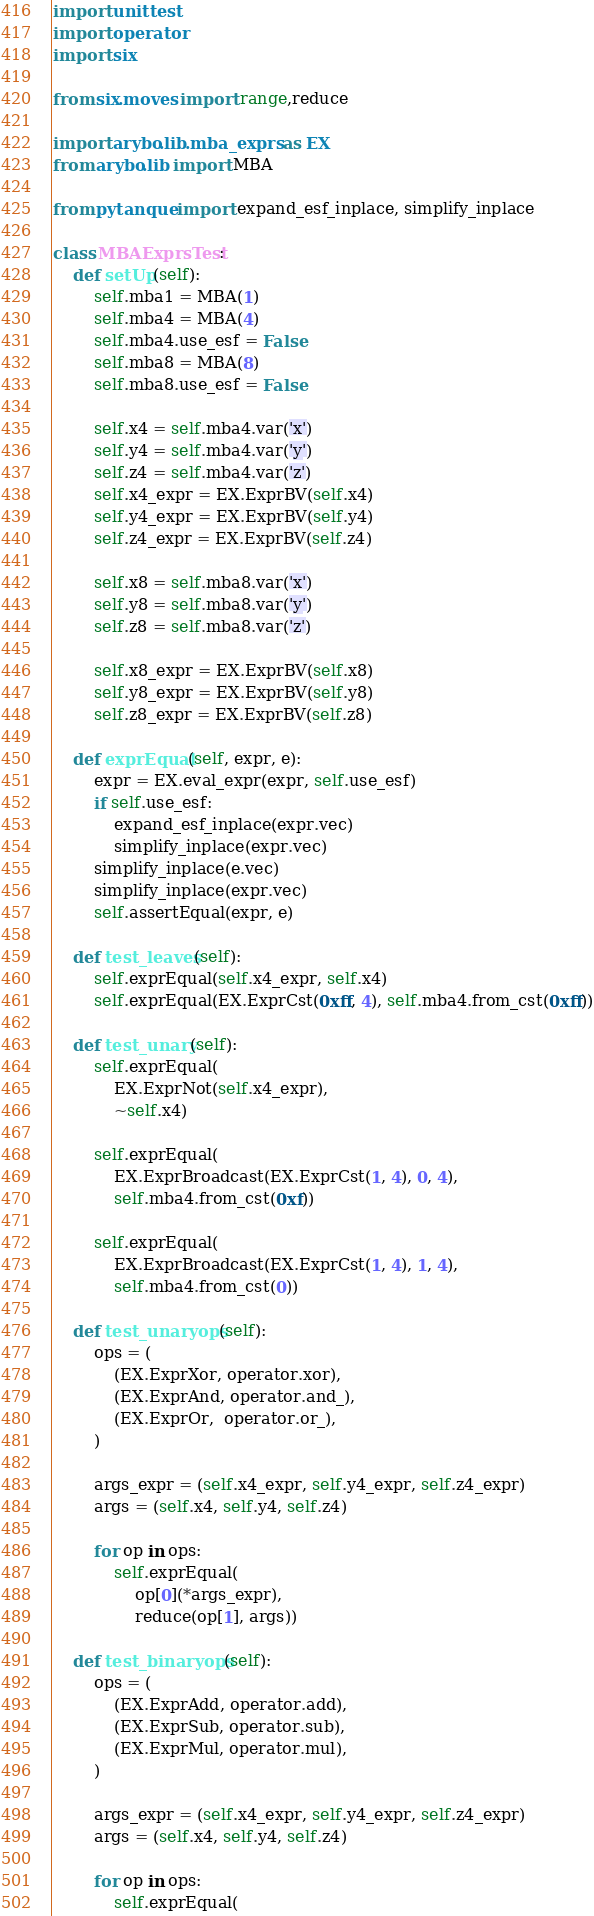<code> <loc_0><loc_0><loc_500><loc_500><_Python_>import unittest
import operator
import six

from six.moves import range,reduce

import arybo.lib.mba_exprs as EX
from arybo.lib import MBA

from pytanque import expand_esf_inplace, simplify_inplace

class MBAExprsTest:
    def setUp(self):
        self.mba1 = MBA(1)
        self.mba4 = MBA(4)
        self.mba4.use_esf = False
        self.mba8 = MBA(8)
        self.mba8.use_esf = False

        self.x4 = self.mba4.var('x')
        self.y4 = self.mba4.var('y')
        self.z4 = self.mba4.var('z')
        self.x4_expr = EX.ExprBV(self.x4)
        self.y4_expr = EX.ExprBV(self.y4)
        self.z4_expr = EX.ExprBV(self.z4)

        self.x8 = self.mba8.var('x')
        self.y8 = self.mba8.var('y')
        self.z8 = self.mba8.var('z')

        self.x8_expr = EX.ExprBV(self.x8)
        self.y8_expr = EX.ExprBV(self.y8)
        self.z8_expr = EX.ExprBV(self.z8)

    def exprEqual(self, expr, e):
        expr = EX.eval_expr(expr, self.use_esf)
        if self.use_esf:
            expand_esf_inplace(expr.vec)
            simplify_inplace(expr.vec)
        simplify_inplace(e.vec)
        simplify_inplace(expr.vec)
        self.assertEqual(expr, e)

    def test_leaves(self):
        self.exprEqual(self.x4_expr, self.x4)
        self.exprEqual(EX.ExprCst(0xff, 4), self.mba4.from_cst(0xff))

    def test_unary(self):
        self.exprEqual(
            EX.ExprNot(self.x4_expr),
            ~self.x4)

        self.exprEqual(
            EX.ExprBroadcast(EX.ExprCst(1, 4), 0, 4),
            self.mba4.from_cst(0xf))

        self.exprEqual(
            EX.ExprBroadcast(EX.ExprCst(1, 4), 1, 4),
            self.mba4.from_cst(0))

    def test_unaryops(self):
        ops = (
            (EX.ExprXor, operator.xor),
            (EX.ExprAnd, operator.and_),
            (EX.ExprOr,  operator.or_),
        )

        args_expr = (self.x4_expr, self.y4_expr, self.z4_expr)
        args = (self.x4, self.y4, self.z4)

        for op in ops:
            self.exprEqual(
                op[0](*args_expr),
                reduce(op[1], args))

    def test_binaryops(self):
        ops = (
            (EX.ExprAdd, operator.add),
            (EX.ExprSub, operator.sub),
            (EX.ExprMul, operator.mul),
        )

        args_expr = (self.x4_expr, self.y4_expr, self.z4_expr)
        args = (self.x4, self.y4, self.z4)

        for op in ops:
            self.exprEqual(</code> 